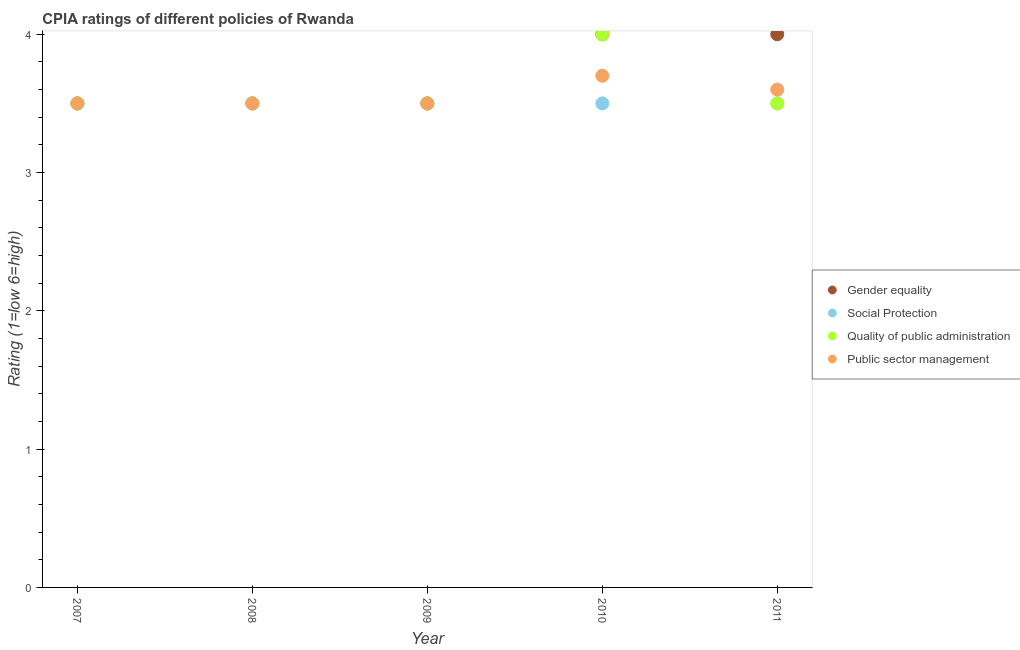What is the cpia rating of social protection in 2009?
Make the answer very short. 3.5. Across all years, what is the minimum cpia rating of social protection?
Make the answer very short. 3.5. What is the total cpia rating of public sector management in the graph?
Make the answer very short. 17.8. What is the difference between the cpia rating of gender equality in 2009 and that in 2010?
Provide a short and direct response. -0.5. In how many years, is the cpia rating of gender equality greater than 2?
Give a very brief answer. 5. Is the cpia rating of quality of public administration in 2009 less than that in 2010?
Offer a terse response. Yes. What is the difference between the highest and the second highest cpia rating of gender equality?
Keep it short and to the point. 0. Is it the case that in every year, the sum of the cpia rating of gender equality and cpia rating of public sector management is greater than the sum of cpia rating of quality of public administration and cpia rating of social protection?
Your response must be concise. No. Is the cpia rating of gender equality strictly greater than the cpia rating of quality of public administration over the years?
Provide a succinct answer. No. How many dotlines are there?
Offer a terse response. 4. How many years are there in the graph?
Offer a very short reply. 5. What is the difference between two consecutive major ticks on the Y-axis?
Make the answer very short. 1. Does the graph contain grids?
Your answer should be compact. No. Where does the legend appear in the graph?
Ensure brevity in your answer.  Center right. How many legend labels are there?
Offer a very short reply. 4. What is the title of the graph?
Your response must be concise. CPIA ratings of different policies of Rwanda. What is the label or title of the Y-axis?
Ensure brevity in your answer.  Rating (1=low 6=high). What is the Rating (1=low 6=high) of Quality of public administration in 2007?
Give a very brief answer. 3.5. What is the Rating (1=low 6=high) of Public sector management in 2007?
Provide a succinct answer. 3.5. What is the Rating (1=low 6=high) in Gender equality in 2009?
Make the answer very short. 3.5. What is the Rating (1=low 6=high) of Public sector management in 2009?
Offer a very short reply. 3.5. What is the Rating (1=low 6=high) in Gender equality in 2010?
Your answer should be compact. 4. What is the Rating (1=low 6=high) in Social Protection in 2010?
Provide a succinct answer. 3.5. What is the Rating (1=low 6=high) in Quality of public administration in 2010?
Offer a terse response. 4. What is the Rating (1=low 6=high) of Social Protection in 2011?
Provide a succinct answer. 3.5. What is the Rating (1=low 6=high) in Quality of public administration in 2011?
Your response must be concise. 3.5. Across all years, what is the maximum Rating (1=low 6=high) of Social Protection?
Offer a very short reply. 3.5. Across all years, what is the maximum Rating (1=low 6=high) in Public sector management?
Offer a very short reply. 3.7. Across all years, what is the minimum Rating (1=low 6=high) of Social Protection?
Offer a very short reply. 3.5. Across all years, what is the minimum Rating (1=low 6=high) in Quality of public administration?
Your answer should be compact. 3.5. Across all years, what is the minimum Rating (1=low 6=high) in Public sector management?
Your answer should be very brief. 3.5. What is the total Rating (1=low 6=high) in Gender equality in the graph?
Provide a short and direct response. 18.5. What is the total Rating (1=low 6=high) in Social Protection in the graph?
Provide a short and direct response. 17.5. What is the total Rating (1=low 6=high) in Public sector management in the graph?
Your answer should be compact. 17.8. What is the difference between the Rating (1=low 6=high) of Gender equality in 2007 and that in 2008?
Offer a very short reply. 0. What is the difference between the Rating (1=low 6=high) in Quality of public administration in 2007 and that in 2008?
Keep it short and to the point. 0. What is the difference between the Rating (1=low 6=high) of Gender equality in 2007 and that in 2009?
Keep it short and to the point. 0. What is the difference between the Rating (1=low 6=high) of Social Protection in 2007 and that in 2009?
Make the answer very short. 0. What is the difference between the Rating (1=low 6=high) of Public sector management in 2007 and that in 2009?
Make the answer very short. 0. What is the difference between the Rating (1=low 6=high) of Gender equality in 2007 and that in 2011?
Your answer should be compact. -0.5. What is the difference between the Rating (1=low 6=high) of Quality of public administration in 2007 and that in 2011?
Offer a terse response. 0. What is the difference between the Rating (1=low 6=high) in Quality of public administration in 2008 and that in 2009?
Give a very brief answer. 0. What is the difference between the Rating (1=low 6=high) of Public sector management in 2008 and that in 2009?
Make the answer very short. 0. What is the difference between the Rating (1=low 6=high) of Quality of public administration in 2008 and that in 2010?
Provide a short and direct response. -0.5. What is the difference between the Rating (1=low 6=high) of Social Protection in 2008 and that in 2011?
Your response must be concise. 0. What is the difference between the Rating (1=low 6=high) of Quality of public administration in 2009 and that in 2010?
Your answer should be very brief. -0.5. What is the difference between the Rating (1=low 6=high) of Public sector management in 2009 and that in 2010?
Your answer should be compact. -0.2. What is the difference between the Rating (1=low 6=high) of Public sector management in 2009 and that in 2011?
Offer a terse response. -0.1. What is the difference between the Rating (1=low 6=high) in Social Protection in 2010 and that in 2011?
Keep it short and to the point. 0. What is the difference between the Rating (1=low 6=high) in Quality of public administration in 2010 and that in 2011?
Your answer should be very brief. 0.5. What is the difference between the Rating (1=low 6=high) in Gender equality in 2007 and the Rating (1=low 6=high) in Social Protection in 2008?
Make the answer very short. 0. What is the difference between the Rating (1=low 6=high) of Social Protection in 2007 and the Rating (1=low 6=high) of Public sector management in 2008?
Offer a terse response. 0. What is the difference between the Rating (1=low 6=high) of Quality of public administration in 2007 and the Rating (1=low 6=high) of Public sector management in 2008?
Make the answer very short. 0. What is the difference between the Rating (1=low 6=high) of Social Protection in 2007 and the Rating (1=low 6=high) of Public sector management in 2009?
Your response must be concise. 0. What is the difference between the Rating (1=low 6=high) in Quality of public administration in 2007 and the Rating (1=low 6=high) in Public sector management in 2009?
Your answer should be compact. 0. What is the difference between the Rating (1=low 6=high) of Gender equality in 2007 and the Rating (1=low 6=high) of Public sector management in 2010?
Offer a very short reply. -0.2. What is the difference between the Rating (1=low 6=high) of Social Protection in 2007 and the Rating (1=low 6=high) of Quality of public administration in 2010?
Provide a succinct answer. -0.5. What is the difference between the Rating (1=low 6=high) in Social Protection in 2007 and the Rating (1=low 6=high) in Public sector management in 2010?
Your answer should be very brief. -0.2. What is the difference between the Rating (1=low 6=high) in Gender equality in 2007 and the Rating (1=low 6=high) in Social Protection in 2011?
Make the answer very short. 0. What is the difference between the Rating (1=low 6=high) in Gender equality in 2007 and the Rating (1=low 6=high) in Quality of public administration in 2011?
Keep it short and to the point. 0. What is the difference between the Rating (1=low 6=high) in Social Protection in 2007 and the Rating (1=low 6=high) in Quality of public administration in 2011?
Give a very brief answer. 0. What is the difference between the Rating (1=low 6=high) of Social Protection in 2007 and the Rating (1=low 6=high) of Public sector management in 2011?
Your answer should be compact. -0.1. What is the difference between the Rating (1=low 6=high) of Gender equality in 2008 and the Rating (1=low 6=high) of Quality of public administration in 2009?
Give a very brief answer. 0. What is the difference between the Rating (1=low 6=high) of Social Protection in 2008 and the Rating (1=low 6=high) of Public sector management in 2009?
Provide a succinct answer. 0. What is the difference between the Rating (1=low 6=high) in Gender equality in 2008 and the Rating (1=low 6=high) in Social Protection in 2010?
Your response must be concise. 0. What is the difference between the Rating (1=low 6=high) of Social Protection in 2008 and the Rating (1=low 6=high) of Quality of public administration in 2010?
Your answer should be compact. -0.5. What is the difference between the Rating (1=low 6=high) in Social Protection in 2008 and the Rating (1=low 6=high) in Public sector management in 2010?
Offer a very short reply. -0.2. What is the difference between the Rating (1=low 6=high) in Quality of public administration in 2008 and the Rating (1=low 6=high) in Public sector management in 2010?
Keep it short and to the point. -0.2. What is the difference between the Rating (1=low 6=high) in Gender equality in 2008 and the Rating (1=low 6=high) in Social Protection in 2011?
Your answer should be very brief. 0. What is the difference between the Rating (1=low 6=high) in Gender equality in 2008 and the Rating (1=low 6=high) in Public sector management in 2011?
Offer a very short reply. -0.1. What is the difference between the Rating (1=low 6=high) of Gender equality in 2009 and the Rating (1=low 6=high) of Social Protection in 2010?
Ensure brevity in your answer.  0. What is the difference between the Rating (1=low 6=high) of Gender equality in 2009 and the Rating (1=low 6=high) of Quality of public administration in 2011?
Your answer should be very brief. 0. What is the difference between the Rating (1=low 6=high) of Social Protection in 2009 and the Rating (1=low 6=high) of Quality of public administration in 2011?
Provide a succinct answer. 0. What is the difference between the Rating (1=low 6=high) of Quality of public administration in 2009 and the Rating (1=low 6=high) of Public sector management in 2011?
Offer a terse response. -0.1. What is the difference between the Rating (1=low 6=high) in Gender equality in 2010 and the Rating (1=low 6=high) in Social Protection in 2011?
Your answer should be very brief. 0.5. What is the difference between the Rating (1=low 6=high) in Gender equality in 2010 and the Rating (1=low 6=high) in Quality of public administration in 2011?
Keep it short and to the point. 0.5. What is the difference between the Rating (1=low 6=high) of Gender equality in 2010 and the Rating (1=low 6=high) of Public sector management in 2011?
Your response must be concise. 0.4. What is the difference between the Rating (1=low 6=high) in Quality of public administration in 2010 and the Rating (1=low 6=high) in Public sector management in 2011?
Your answer should be compact. 0.4. What is the average Rating (1=low 6=high) in Social Protection per year?
Keep it short and to the point. 3.5. What is the average Rating (1=low 6=high) of Public sector management per year?
Your answer should be very brief. 3.56. In the year 2007, what is the difference between the Rating (1=low 6=high) in Gender equality and Rating (1=low 6=high) in Social Protection?
Offer a terse response. 0. In the year 2007, what is the difference between the Rating (1=low 6=high) in Gender equality and Rating (1=low 6=high) in Quality of public administration?
Provide a short and direct response. 0. In the year 2007, what is the difference between the Rating (1=low 6=high) in Social Protection and Rating (1=low 6=high) in Quality of public administration?
Provide a short and direct response. 0. In the year 2007, what is the difference between the Rating (1=low 6=high) in Quality of public administration and Rating (1=low 6=high) in Public sector management?
Your answer should be very brief. 0. In the year 2008, what is the difference between the Rating (1=low 6=high) of Gender equality and Rating (1=low 6=high) of Social Protection?
Your answer should be compact. 0. In the year 2008, what is the difference between the Rating (1=low 6=high) of Gender equality and Rating (1=low 6=high) of Public sector management?
Provide a succinct answer. 0. In the year 2008, what is the difference between the Rating (1=low 6=high) of Social Protection and Rating (1=low 6=high) of Public sector management?
Give a very brief answer. 0. In the year 2009, what is the difference between the Rating (1=low 6=high) of Gender equality and Rating (1=low 6=high) of Quality of public administration?
Give a very brief answer. 0. In the year 2009, what is the difference between the Rating (1=low 6=high) in Social Protection and Rating (1=low 6=high) in Quality of public administration?
Ensure brevity in your answer.  0. In the year 2009, what is the difference between the Rating (1=low 6=high) in Social Protection and Rating (1=low 6=high) in Public sector management?
Offer a terse response. 0. In the year 2009, what is the difference between the Rating (1=low 6=high) of Quality of public administration and Rating (1=low 6=high) of Public sector management?
Make the answer very short. 0. In the year 2010, what is the difference between the Rating (1=low 6=high) in Gender equality and Rating (1=low 6=high) in Social Protection?
Your response must be concise. 0.5. In the year 2010, what is the difference between the Rating (1=low 6=high) in Social Protection and Rating (1=low 6=high) in Quality of public administration?
Offer a very short reply. -0.5. In the year 2011, what is the difference between the Rating (1=low 6=high) in Gender equality and Rating (1=low 6=high) in Social Protection?
Your answer should be compact. 0.5. In the year 2011, what is the difference between the Rating (1=low 6=high) of Gender equality and Rating (1=low 6=high) of Quality of public administration?
Your answer should be very brief. 0.5. In the year 2011, what is the difference between the Rating (1=low 6=high) of Gender equality and Rating (1=low 6=high) of Public sector management?
Provide a succinct answer. 0.4. In the year 2011, what is the difference between the Rating (1=low 6=high) of Social Protection and Rating (1=low 6=high) of Public sector management?
Offer a very short reply. -0.1. In the year 2011, what is the difference between the Rating (1=low 6=high) in Quality of public administration and Rating (1=low 6=high) in Public sector management?
Offer a very short reply. -0.1. What is the ratio of the Rating (1=low 6=high) in Gender equality in 2007 to that in 2008?
Offer a terse response. 1. What is the ratio of the Rating (1=low 6=high) of Social Protection in 2007 to that in 2008?
Your answer should be very brief. 1. What is the ratio of the Rating (1=low 6=high) of Quality of public administration in 2007 to that in 2008?
Ensure brevity in your answer.  1. What is the ratio of the Rating (1=low 6=high) in Social Protection in 2007 to that in 2009?
Keep it short and to the point. 1. What is the ratio of the Rating (1=low 6=high) of Quality of public administration in 2007 to that in 2009?
Your response must be concise. 1. What is the ratio of the Rating (1=low 6=high) in Gender equality in 2007 to that in 2010?
Give a very brief answer. 0.88. What is the ratio of the Rating (1=low 6=high) in Social Protection in 2007 to that in 2010?
Provide a short and direct response. 1. What is the ratio of the Rating (1=low 6=high) in Quality of public administration in 2007 to that in 2010?
Provide a short and direct response. 0.88. What is the ratio of the Rating (1=low 6=high) in Public sector management in 2007 to that in 2010?
Make the answer very short. 0.95. What is the ratio of the Rating (1=low 6=high) in Gender equality in 2007 to that in 2011?
Give a very brief answer. 0.88. What is the ratio of the Rating (1=low 6=high) in Public sector management in 2007 to that in 2011?
Keep it short and to the point. 0.97. What is the ratio of the Rating (1=low 6=high) of Social Protection in 2008 to that in 2009?
Make the answer very short. 1. What is the ratio of the Rating (1=low 6=high) of Quality of public administration in 2008 to that in 2009?
Your answer should be very brief. 1. What is the ratio of the Rating (1=low 6=high) in Gender equality in 2008 to that in 2010?
Keep it short and to the point. 0.88. What is the ratio of the Rating (1=low 6=high) in Public sector management in 2008 to that in 2010?
Your response must be concise. 0.95. What is the ratio of the Rating (1=low 6=high) of Gender equality in 2008 to that in 2011?
Ensure brevity in your answer.  0.88. What is the ratio of the Rating (1=low 6=high) in Social Protection in 2008 to that in 2011?
Offer a very short reply. 1. What is the ratio of the Rating (1=low 6=high) of Public sector management in 2008 to that in 2011?
Make the answer very short. 0.97. What is the ratio of the Rating (1=low 6=high) in Gender equality in 2009 to that in 2010?
Keep it short and to the point. 0.88. What is the ratio of the Rating (1=low 6=high) of Quality of public administration in 2009 to that in 2010?
Provide a succinct answer. 0.88. What is the ratio of the Rating (1=low 6=high) of Public sector management in 2009 to that in 2010?
Keep it short and to the point. 0.95. What is the ratio of the Rating (1=low 6=high) of Quality of public administration in 2009 to that in 2011?
Provide a short and direct response. 1. What is the ratio of the Rating (1=low 6=high) of Public sector management in 2009 to that in 2011?
Ensure brevity in your answer.  0.97. What is the ratio of the Rating (1=low 6=high) of Gender equality in 2010 to that in 2011?
Keep it short and to the point. 1. What is the ratio of the Rating (1=low 6=high) in Social Protection in 2010 to that in 2011?
Give a very brief answer. 1. What is the ratio of the Rating (1=low 6=high) of Public sector management in 2010 to that in 2011?
Make the answer very short. 1.03. What is the difference between the highest and the second highest Rating (1=low 6=high) of Gender equality?
Make the answer very short. 0. What is the difference between the highest and the second highest Rating (1=low 6=high) of Quality of public administration?
Your answer should be compact. 0.5. What is the difference between the highest and the second highest Rating (1=low 6=high) in Public sector management?
Your response must be concise. 0.1. What is the difference between the highest and the lowest Rating (1=low 6=high) of Social Protection?
Ensure brevity in your answer.  0. 